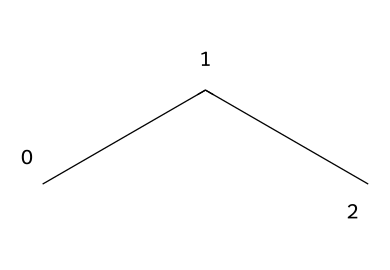What is the name of this refrigerant? The SMILES representation "CCC" corresponds to propane, commonly denoted as R-290 when used as a refrigerant.
Answer: propane How many carbon atoms are present in this structure? The SMILES "CCC" indicates three carbon atoms arranged in a chain, each represented by the letter 'C'.
Answer: three What type of bonds are present between the carbon atoms? The structure indicates single bonds between the carbon atoms within the propane molecule, as it follows the alkane category.
Answer: single bonds What is the molecular formula of propane? From the chemical structure "CCC," there are three carbon atoms and eight hydrogen atoms, leading to the formula C3H8.
Answer: C3H8 Is propane classified as a hydrocarbon? Propane consists solely of carbon and hydrogen atoms, confirming that it falls under the hydrocarbon classification.
Answer: yes How many hydrogen atoms are bonded to the propane structure? For every carbon in propane (C3H8), there are a total of eight hydrogen atoms bonded according to the structure.
Answer: eight Why is propane considered an environmentally friendly refrigerant? Propane is considered environmentally friendly due to its low global warming potential and is safe to use compared to many traditional refrigerants.
Answer: low GWP 